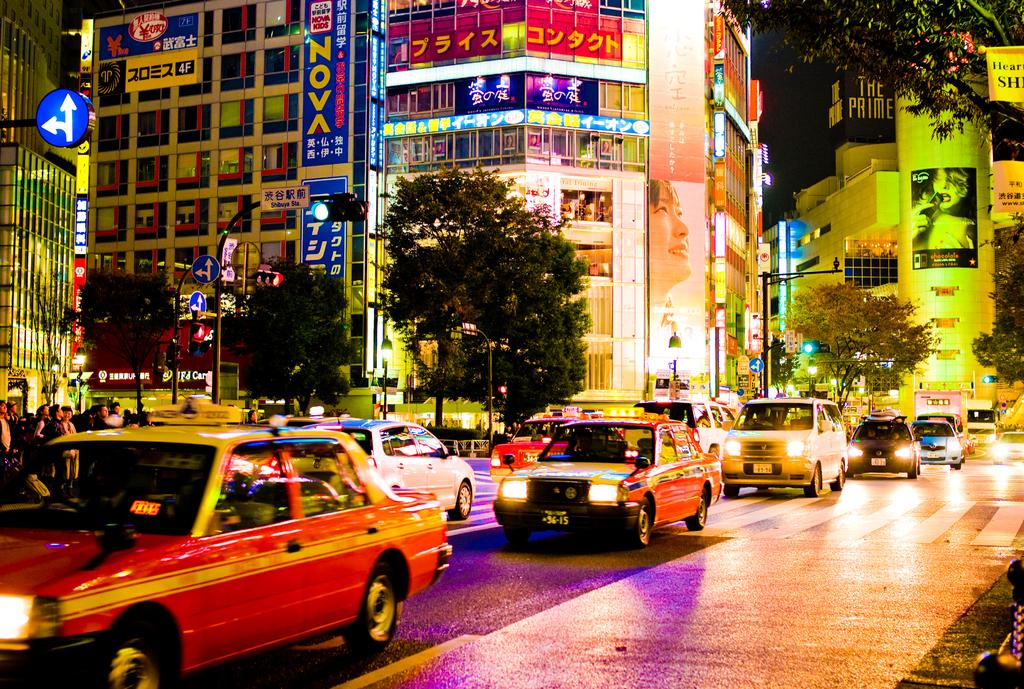<image>
Present a compact description of the photo's key features. A night time city street with taxis and a sign that says Nova. 